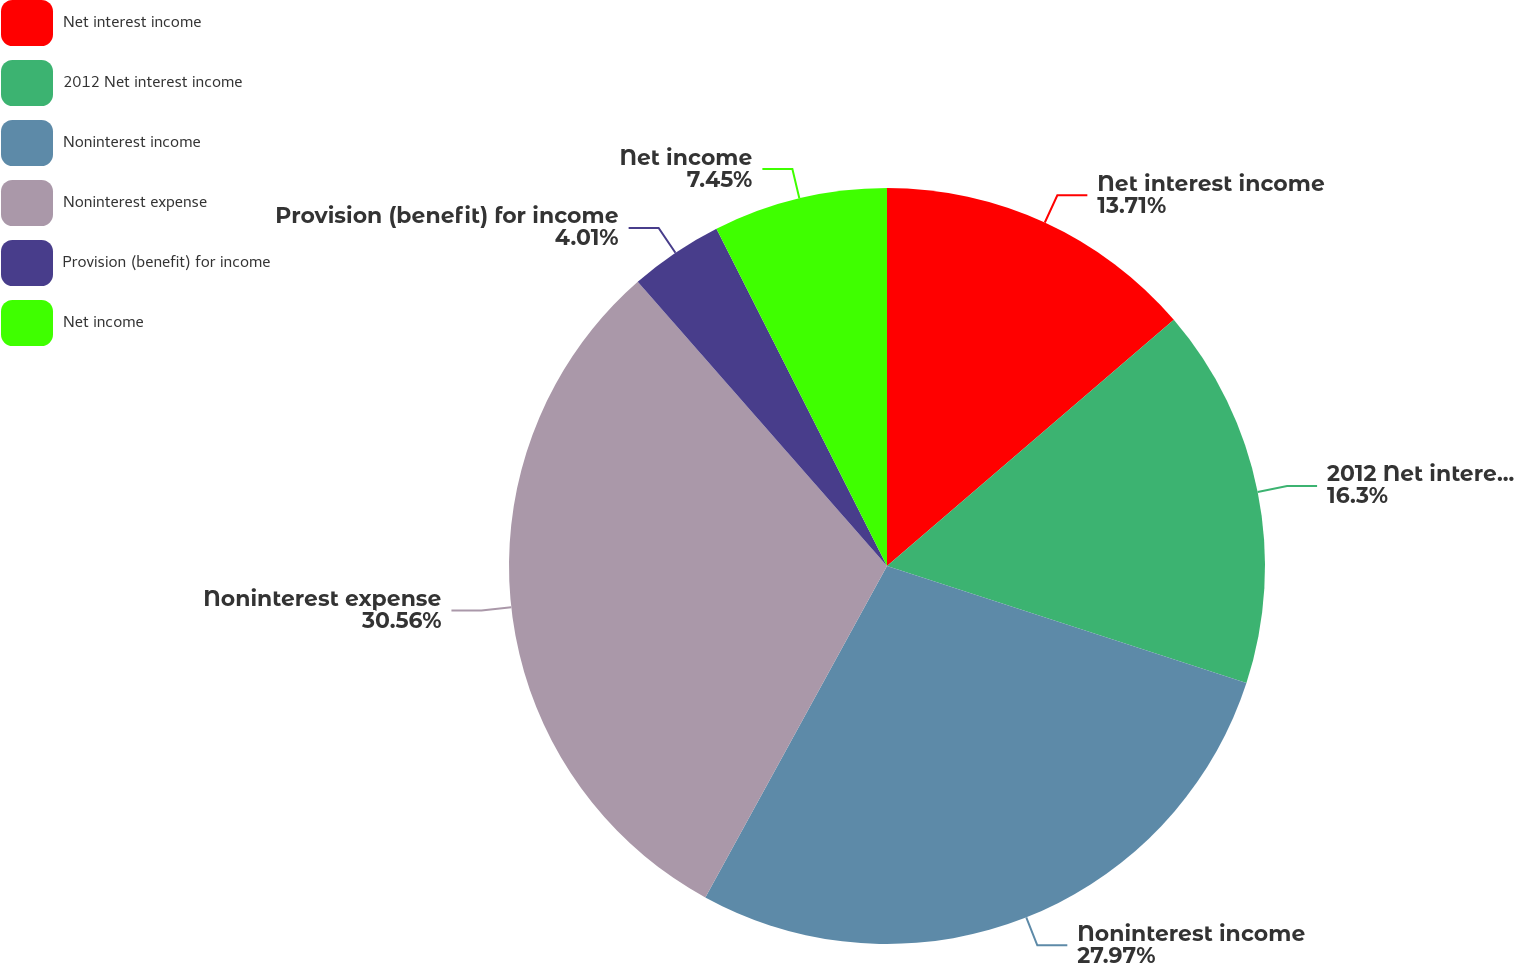Convert chart. <chart><loc_0><loc_0><loc_500><loc_500><pie_chart><fcel>Net interest income<fcel>2012 Net interest income<fcel>Noninterest income<fcel>Noninterest expense<fcel>Provision (benefit) for income<fcel>Net income<nl><fcel>13.71%<fcel>16.3%<fcel>27.97%<fcel>30.56%<fcel>4.01%<fcel>7.45%<nl></chart> 